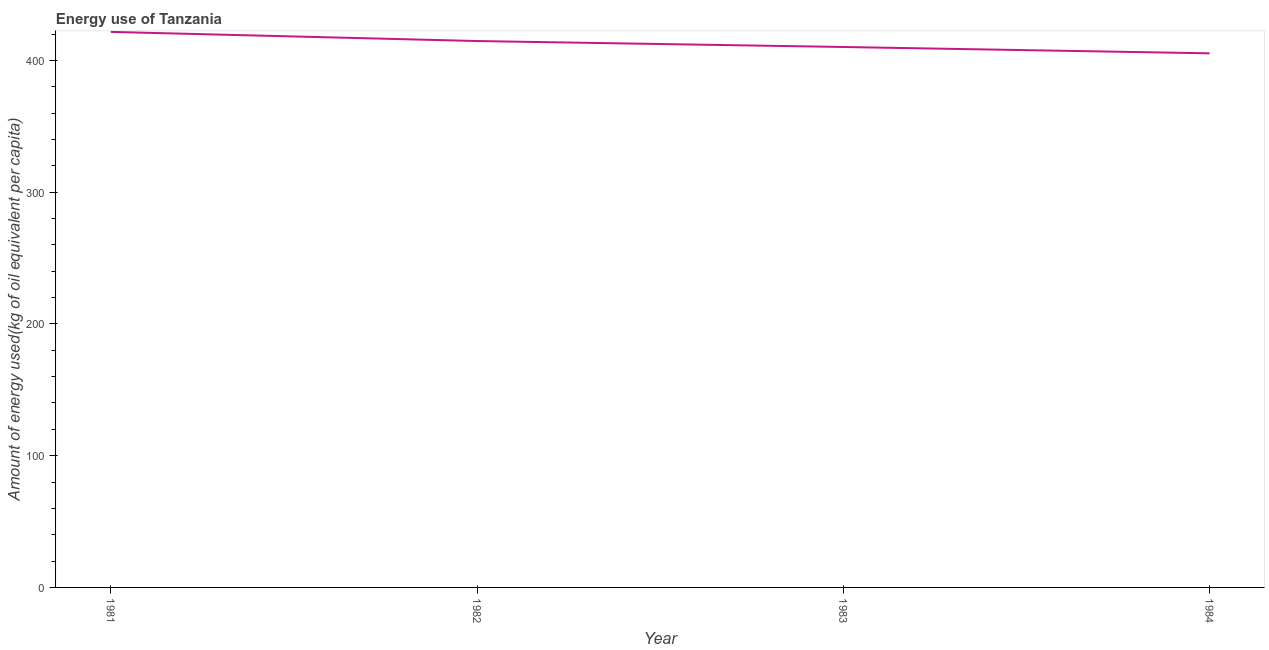What is the amount of energy used in 1983?
Give a very brief answer. 410.19. Across all years, what is the maximum amount of energy used?
Your answer should be compact. 421.64. Across all years, what is the minimum amount of energy used?
Give a very brief answer. 405.39. In which year was the amount of energy used maximum?
Provide a short and direct response. 1981. In which year was the amount of energy used minimum?
Keep it short and to the point. 1984. What is the sum of the amount of energy used?
Your response must be concise. 1651.93. What is the difference between the amount of energy used in 1982 and 1984?
Ensure brevity in your answer.  9.32. What is the average amount of energy used per year?
Ensure brevity in your answer.  412.98. What is the median amount of energy used?
Your response must be concise. 412.45. What is the ratio of the amount of energy used in 1981 to that in 1984?
Provide a short and direct response. 1.04. Is the amount of energy used in 1981 less than that in 1983?
Offer a terse response. No. Is the difference between the amount of energy used in 1981 and 1982 greater than the difference between any two years?
Make the answer very short. No. What is the difference between the highest and the second highest amount of energy used?
Offer a terse response. 6.94. Is the sum of the amount of energy used in 1982 and 1983 greater than the maximum amount of energy used across all years?
Your response must be concise. Yes. What is the difference between the highest and the lowest amount of energy used?
Keep it short and to the point. 16.26. How many lines are there?
Provide a succinct answer. 1. How many years are there in the graph?
Provide a succinct answer. 4. What is the difference between two consecutive major ticks on the Y-axis?
Offer a very short reply. 100. Does the graph contain any zero values?
Your answer should be very brief. No. Does the graph contain grids?
Offer a terse response. No. What is the title of the graph?
Your answer should be very brief. Energy use of Tanzania. What is the label or title of the X-axis?
Provide a succinct answer. Year. What is the label or title of the Y-axis?
Ensure brevity in your answer.  Amount of energy used(kg of oil equivalent per capita). What is the Amount of energy used(kg of oil equivalent per capita) in 1981?
Provide a succinct answer. 421.64. What is the Amount of energy used(kg of oil equivalent per capita) of 1982?
Offer a terse response. 414.71. What is the Amount of energy used(kg of oil equivalent per capita) in 1983?
Provide a short and direct response. 410.19. What is the Amount of energy used(kg of oil equivalent per capita) of 1984?
Make the answer very short. 405.39. What is the difference between the Amount of energy used(kg of oil equivalent per capita) in 1981 and 1982?
Your response must be concise. 6.94. What is the difference between the Amount of energy used(kg of oil equivalent per capita) in 1981 and 1983?
Provide a succinct answer. 11.46. What is the difference between the Amount of energy used(kg of oil equivalent per capita) in 1981 and 1984?
Make the answer very short. 16.26. What is the difference between the Amount of energy used(kg of oil equivalent per capita) in 1982 and 1983?
Offer a terse response. 4.52. What is the difference between the Amount of energy used(kg of oil equivalent per capita) in 1982 and 1984?
Your answer should be compact. 9.32. What is the difference between the Amount of energy used(kg of oil equivalent per capita) in 1983 and 1984?
Offer a terse response. 4.8. What is the ratio of the Amount of energy used(kg of oil equivalent per capita) in 1981 to that in 1983?
Your response must be concise. 1.03. What is the ratio of the Amount of energy used(kg of oil equivalent per capita) in 1982 to that in 1984?
Your response must be concise. 1.02. What is the ratio of the Amount of energy used(kg of oil equivalent per capita) in 1983 to that in 1984?
Your answer should be very brief. 1.01. 